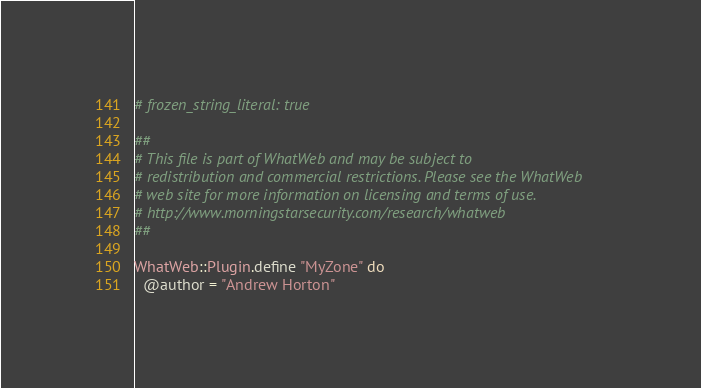Convert code to text. <code><loc_0><loc_0><loc_500><loc_500><_Ruby_># frozen_string_literal: true

##
# This file is part of WhatWeb and may be subject to
# redistribution and commercial restrictions. Please see the WhatWeb
# web site for more information on licensing and terms of use.
# http://www.morningstarsecurity.com/research/whatweb
##

WhatWeb::Plugin.define "MyZone" do
  @author = "Andrew Horton"</code> 